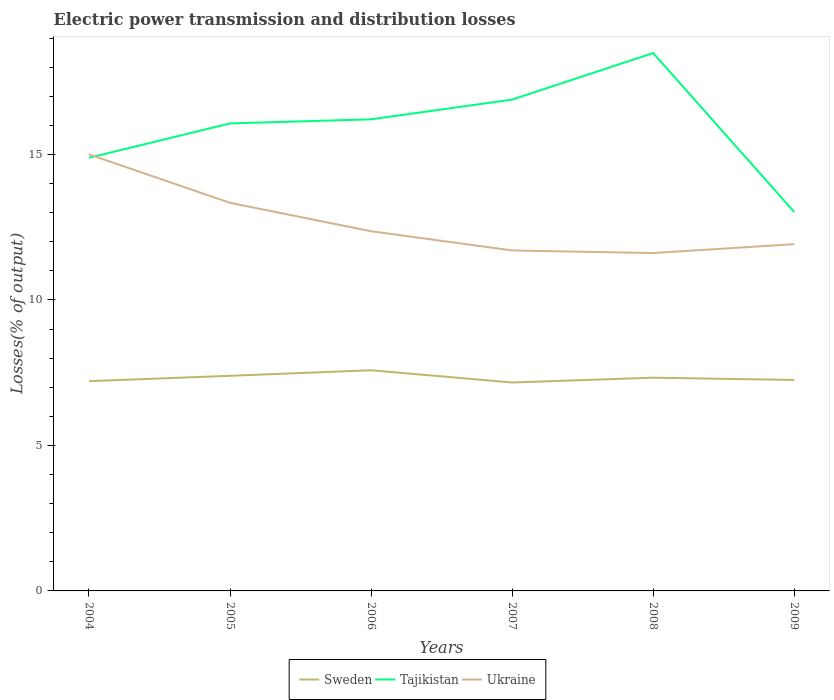Does the line corresponding to Ukraine intersect with the line corresponding to Tajikistan?
Give a very brief answer. Yes. Across all years, what is the maximum electric power transmission and distribution losses in Ukraine?
Your answer should be compact. 11.61. What is the total electric power transmission and distribution losses in Sweden in the graph?
Your response must be concise. -0.18. What is the difference between the highest and the second highest electric power transmission and distribution losses in Ukraine?
Keep it short and to the point. 3.39. What is the difference between the highest and the lowest electric power transmission and distribution losses in Sweden?
Provide a short and direct response. 3. Is the electric power transmission and distribution losses in Sweden strictly greater than the electric power transmission and distribution losses in Ukraine over the years?
Provide a short and direct response. Yes. How many years are there in the graph?
Your answer should be very brief. 6. What is the difference between two consecutive major ticks on the Y-axis?
Provide a succinct answer. 5. Where does the legend appear in the graph?
Ensure brevity in your answer.  Bottom center. How are the legend labels stacked?
Make the answer very short. Horizontal. What is the title of the graph?
Make the answer very short. Electric power transmission and distribution losses. What is the label or title of the Y-axis?
Offer a very short reply. Losses(% of output). What is the Losses(% of output) of Sweden in 2004?
Your response must be concise. 7.21. What is the Losses(% of output) in Tajikistan in 2004?
Keep it short and to the point. 14.89. What is the Losses(% of output) in Ukraine in 2004?
Your answer should be very brief. 15. What is the Losses(% of output) of Sweden in 2005?
Provide a succinct answer. 7.39. What is the Losses(% of output) of Tajikistan in 2005?
Your answer should be compact. 16.07. What is the Losses(% of output) in Ukraine in 2005?
Your answer should be very brief. 13.34. What is the Losses(% of output) in Sweden in 2006?
Provide a short and direct response. 7.58. What is the Losses(% of output) in Tajikistan in 2006?
Provide a succinct answer. 16.21. What is the Losses(% of output) in Ukraine in 2006?
Provide a succinct answer. 12.36. What is the Losses(% of output) in Sweden in 2007?
Offer a terse response. 7.16. What is the Losses(% of output) in Tajikistan in 2007?
Your answer should be very brief. 16.89. What is the Losses(% of output) in Ukraine in 2007?
Keep it short and to the point. 11.7. What is the Losses(% of output) in Sweden in 2008?
Give a very brief answer. 7.33. What is the Losses(% of output) of Tajikistan in 2008?
Make the answer very short. 18.49. What is the Losses(% of output) of Ukraine in 2008?
Keep it short and to the point. 11.61. What is the Losses(% of output) of Sweden in 2009?
Your answer should be very brief. 7.25. What is the Losses(% of output) in Tajikistan in 2009?
Make the answer very short. 13.02. What is the Losses(% of output) in Ukraine in 2009?
Give a very brief answer. 11.92. Across all years, what is the maximum Losses(% of output) in Sweden?
Keep it short and to the point. 7.58. Across all years, what is the maximum Losses(% of output) of Tajikistan?
Your answer should be compact. 18.49. Across all years, what is the maximum Losses(% of output) in Ukraine?
Make the answer very short. 15. Across all years, what is the minimum Losses(% of output) of Sweden?
Provide a short and direct response. 7.16. Across all years, what is the minimum Losses(% of output) of Tajikistan?
Offer a terse response. 13.02. Across all years, what is the minimum Losses(% of output) in Ukraine?
Your answer should be very brief. 11.61. What is the total Losses(% of output) in Sweden in the graph?
Provide a succinct answer. 43.93. What is the total Losses(% of output) of Tajikistan in the graph?
Give a very brief answer. 95.56. What is the total Losses(% of output) in Ukraine in the graph?
Offer a terse response. 75.94. What is the difference between the Losses(% of output) of Sweden in 2004 and that in 2005?
Make the answer very short. -0.18. What is the difference between the Losses(% of output) of Tajikistan in 2004 and that in 2005?
Make the answer very short. -1.18. What is the difference between the Losses(% of output) in Ukraine in 2004 and that in 2005?
Your answer should be very brief. 1.67. What is the difference between the Losses(% of output) in Sweden in 2004 and that in 2006?
Offer a very short reply. -0.37. What is the difference between the Losses(% of output) of Tajikistan in 2004 and that in 2006?
Your answer should be very brief. -1.32. What is the difference between the Losses(% of output) of Ukraine in 2004 and that in 2006?
Make the answer very short. 2.64. What is the difference between the Losses(% of output) of Sweden in 2004 and that in 2007?
Make the answer very short. 0.05. What is the difference between the Losses(% of output) of Tajikistan in 2004 and that in 2007?
Your response must be concise. -2. What is the difference between the Losses(% of output) in Ukraine in 2004 and that in 2007?
Offer a very short reply. 3.3. What is the difference between the Losses(% of output) of Sweden in 2004 and that in 2008?
Your answer should be very brief. -0.12. What is the difference between the Losses(% of output) of Tajikistan in 2004 and that in 2008?
Your answer should be compact. -3.6. What is the difference between the Losses(% of output) in Ukraine in 2004 and that in 2008?
Offer a terse response. 3.39. What is the difference between the Losses(% of output) in Sweden in 2004 and that in 2009?
Give a very brief answer. -0.04. What is the difference between the Losses(% of output) of Tajikistan in 2004 and that in 2009?
Your answer should be compact. 1.86. What is the difference between the Losses(% of output) in Ukraine in 2004 and that in 2009?
Offer a very short reply. 3.09. What is the difference between the Losses(% of output) in Sweden in 2005 and that in 2006?
Provide a succinct answer. -0.19. What is the difference between the Losses(% of output) of Tajikistan in 2005 and that in 2006?
Offer a very short reply. -0.14. What is the difference between the Losses(% of output) of Ukraine in 2005 and that in 2006?
Keep it short and to the point. 0.98. What is the difference between the Losses(% of output) in Sweden in 2005 and that in 2007?
Your response must be concise. 0.23. What is the difference between the Losses(% of output) in Tajikistan in 2005 and that in 2007?
Give a very brief answer. -0.82. What is the difference between the Losses(% of output) of Ukraine in 2005 and that in 2007?
Make the answer very short. 1.64. What is the difference between the Losses(% of output) of Sweden in 2005 and that in 2008?
Give a very brief answer. 0.07. What is the difference between the Losses(% of output) of Tajikistan in 2005 and that in 2008?
Your response must be concise. -2.42. What is the difference between the Losses(% of output) of Ukraine in 2005 and that in 2008?
Ensure brevity in your answer.  1.73. What is the difference between the Losses(% of output) of Sweden in 2005 and that in 2009?
Offer a terse response. 0.14. What is the difference between the Losses(% of output) of Tajikistan in 2005 and that in 2009?
Your response must be concise. 3.04. What is the difference between the Losses(% of output) in Ukraine in 2005 and that in 2009?
Provide a succinct answer. 1.42. What is the difference between the Losses(% of output) of Sweden in 2006 and that in 2007?
Offer a terse response. 0.42. What is the difference between the Losses(% of output) in Tajikistan in 2006 and that in 2007?
Provide a succinct answer. -0.68. What is the difference between the Losses(% of output) in Ukraine in 2006 and that in 2007?
Give a very brief answer. 0.66. What is the difference between the Losses(% of output) of Sweden in 2006 and that in 2008?
Your response must be concise. 0.26. What is the difference between the Losses(% of output) of Tajikistan in 2006 and that in 2008?
Make the answer very short. -2.28. What is the difference between the Losses(% of output) of Ukraine in 2006 and that in 2008?
Keep it short and to the point. 0.75. What is the difference between the Losses(% of output) of Sweden in 2006 and that in 2009?
Your response must be concise. 0.33. What is the difference between the Losses(% of output) in Tajikistan in 2006 and that in 2009?
Ensure brevity in your answer.  3.19. What is the difference between the Losses(% of output) of Ukraine in 2006 and that in 2009?
Your answer should be very brief. 0.44. What is the difference between the Losses(% of output) in Sweden in 2007 and that in 2008?
Make the answer very short. -0.17. What is the difference between the Losses(% of output) of Tajikistan in 2007 and that in 2008?
Make the answer very short. -1.6. What is the difference between the Losses(% of output) in Ukraine in 2007 and that in 2008?
Provide a succinct answer. 0.09. What is the difference between the Losses(% of output) in Sweden in 2007 and that in 2009?
Keep it short and to the point. -0.09. What is the difference between the Losses(% of output) in Tajikistan in 2007 and that in 2009?
Your response must be concise. 3.86. What is the difference between the Losses(% of output) of Ukraine in 2007 and that in 2009?
Provide a short and direct response. -0.22. What is the difference between the Losses(% of output) in Sweden in 2008 and that in 2009?
Provide a short and direct response. 0.08. What is the difference between the Losses(% of output) in Tajikistan in 2008 and that in 2009?
Provide a succinct answer. 5.46. What is the difference between the Losses(% of output) of Ukraine in 2008 and that in 2009?
Ensure brevity in your answer.  -0.31. What is the difference between the Losses(% of output) of Sweden in 2004 and the Losses(% of output) of Tajikistan in 2005?
Provide a short and direct response. -8.86. What is the difference between the Losses(% of output) of Sweden in 2004 and the Losses(% of output) of Ukraine in 2005?
Your answer should be compact. -6.13. What is the difference between the Losses(% of output) of Tajikistan in 2004 and the Losses(% of output) of Ukraine in 2005?
Offer a very short reply. 1.55. What is the difference between the Losses(% of output) in Sweden in 2004 and the Losses(% of output) in Tajikistan in 2006?
Your answer should be compact. -9. What is the difference between the Losses(% of output) in Sweden in 2004 and the Losses(% of output) in Ukraine in 2006?
Your response must be concise. -5.15. What is the difference between the Losses(% of output) of Tajikistan in 2004 and the Losses(% of output) of Ukraine in 2006?
Provide a succinct answer. 2.52. What is the difference between the Losses(% of output) in Sweden in 2004 and the Losses(% of output) in Tajikistan in 2007?
Keep it short and to the point. -9.68. What is the difference between the Losses(% of output) in Sweden in 2004 and the Losses(% of output) in Ukraine in 2007?
Offer a terse response. -4.49. What is the difference between the Losses(% of output) in Tajikistan in 2004 and the Losses(% of output) in Ukraine in 2007?
Your answer should be very brief. 3.18. What is the difference between the Losses(% of output) of Sweden in 2004 and the Losses(% of output) of Tajikistan in 2008?
Your answer should be very brief. -11.28. What is the difference between the Losses(% of output) of Sweden in 2004 and the Losses(% of output) of Ukraine in 2008?
Your response must be concise. -4.4. What is the difference between the Losses(% of output) in Tajikistan in 2004 and the Losses(% of output) in Ukraine in 2008?
Make the answer very short. 3.27. What is the difference between the Losses(% of output) of Sweden in 2004 and the Losses(% of output) of Tajikistan in 2009?
Your response must be concise. -5.81. What is the difference between the Losses(% of output) of Sweden in 2004 and the Losses(% of output) of Ukraine in 2009?
Your answer should be very brief. -4.71. What is the difference between the Losses(% of output) of Tajikistan in 2004 and the Losses(% of output) of Ukraine in 2009?
Make the answer very short. 2.97. What is the difference between the Losses(% of output) of Sweden in 2005 and the Losses(% of output) of Tajikistan in 2006?
Ensure brevity in your answer.  -8.82. What is the difference between the Losses(% of output) of Sweden in 2005 and the Losses(% of output) of Ukraine in 2006?
Provide a succinct answer. -4.97. What is the difference between the Losses(% of output) of Tajikistan in 2005 and the Losses(% of output) of Ukraine in 2006?
Give a very brief answer. 3.71. What is the difference between the Losses(% of output) in Sweden in 2005 and the Losses(% of output) in Tajikistan in 2007?
Make the answer very short. -9.49. What is the difference between the Losses(% of output) in Sweden in 2005 and the Losses(% of output) in Ukraine in 2007?
Your response must be concise. -4.31. What is the difference between the Losses(% of output) in Tajikistan in 2005 and the Losses(% of output) in Ukraine in 2007?
Give a very brief answer. 4.37. What is the difference between the Losses(% of output) of Sweden in 2005 and the Losses(% of output) of Tajikistan in 2008?
Offer a terse response. -11.09. What is the difference between the Losses(% of output) of Sweden in 2005 and the Losses(% of output) of Ukraine in 2008?
Offer a terse response. -4.22. What is the difference between the Losses(% of output) of Tajikistan in 2005 and the Losses(% of output) of Ukraine in 2008?
Ensure brevity in your answer.  4.46. What is the difference between the Losses(% of output) in Sweden in 2005 and the Losses(% of output) in Tajikistan in 2009?
Provide a short and direct response. -5.63. What is the difference between the Losses(% of output) of Sweden in 2005 and the Losses(% of output) of Ukraine in 2009?
Your response must be concise. -4.52. What is the difference between the Losses(% of output) of Tajikistan in 2005 and the Losses(% of output) of Ukraine in 2009?
Your response must be concise. 4.15. What is the difference between the Losses(% of output) of Sweden in 2006 and the Losses(% of output) of Tajikistan in 2007?
Keep it short and to the point. -9.3. What is the difference between the Losses(% of output) of Sweden in 2006 and the Losses(% of output) of Ukraine in 2007?
Ensure brevity in your answer.  -4.12. What is the difference between the Losses(% of output) of Tajikistan in 2006 and the Losses(% of output) of Ukraine in 2007?
Ensure brevity in your answer.  4.51. What is the difference between the Losses(% of output) in Sweden in 2006 and the Losses(% of output) in Tajikistan in 2008?
Your answer should be very brief. -10.9. What is the difference between the Losses(% of output) in Sweden in 2006 and the Losses(% of output) in Ukraine in 2008?
Offer a very short reply. -4.03. What is the difference between the Losses(% of output) of Tajikistan in 2006 and the Losses(% of output) of Ukraine in 2008?
Your response must be concise. 4.6. What is the difference between the Losses(% of output) in Sweden in 2006 and the Losses(% of output) in Tajikistan in 2009?
Give a very brief answer. -5.44. What is the difference between the Losses(% of output) in Sweden in 2006 and the Losses(% of output) in Ukraine in 2009?
Your response must be concise. -4.33. What is the difference between the Losses(% of output) of Tajikistan in 2006 and the Losses(% of output) of Ukraine in 2009?
Provide a short and direct response. 4.29. What is the difference between the Losses(% of output) in Sweden in 2007 and the Losses(% of output) in Tajikistan in 2008?
Give a very brief answer. -11.32. What is the difference between the Losses(% of output) in Sweden in 2007 and the Losses(% of output) in Ukraine in 2008?
Your response must be concise. -4.45. What is the difference between the Losses(% of output) in Tajikistan in 2007 and the Losses(% of output) in Ukraine in 2008?
Ensure brevity in your answer.  5.27. What is the difference between the Losses(% of output) in Sweden in 2007 and the Losses(% of output) in Tajikistan in 2009?
Your response must be concise. -5.86. What is the difference between the Losses(% of output) of Sweden in 2007 and the Losses(% of output) of Ukraine in 2009?
Ensure brevity in your answer.  -4.75. What is the difference between the Losses(% of output) of Tajikistan in 2007 and the Losses(% of output) of Ukraine in 2009?
Your response must be concise. 4.97. What is the difference between the Losses(% of output) of Sweden in 2008 and the Losses(% of output) of Tajikistan in 2009?
Make the answer very short. -5.7. What is the difference between the Losses(% of output) in Sweden in 2008 and the Losses(% of output) in Ukraine in 2009?
Provide a succinct answer. -4.59. What is the difference between the Losses(% of output) in Tajikistan in 2008 and the Losses(% of output) in Ukraine in 2009?
Provide a short and direct response. 6.57. What is the average Losses(% of output) of Sweden per year?
Offer a very short reply. 7.32. What is the average Losses(% of output) in Tajikistan per year?
Offer a terse response. 15.93. What is the average Losses(% of output) in Ukraine per year?
Give a very brief answer. 12.66. In the year 2004, what is the difference between the Losses(% of output) in Sweden and Losses(% of output) in Tajikistan?
Keep it short and to the point. -7.68. In the year 2004, what is the difference between the Losses(% of output) of Sweden and Losses(% of output) of Ukraine?
Your answer should be compact. -7.79. In the year 2004, what is the difference between the Losses(% of output) in Tajikistan and Losses(% of output) in Ukraine?
Offer a terse response. -0.12. In the year 2005, what is the difference between the Losses(% of output) in Sweden and Losses(% of output) in Tajikistan?
Provide a short and direct response. -8.67. In the year 2005, what is the difference between the Losses(% of output) of Sweden and Losses(% of output) of Ukraine?
Your answer should be compact. -5.94. In the year 2005, what is the difference between the Losses(% of output) in Tajikistan and Losses(% of output) in Ukraine?
Provide a short and direct response. 2.73. In the year 2006, what is the difference between the Losses(% of output) of Sweden and Losses(% of output) of Tajikistan?
Give a very brief answer. -8.62. In the year 2006, what is the difference between the Losses(% of output) of Sweden and Losses(% of output) of Ukraine?
Your response must be concise. -4.78. In the year 2006, what is the difference between the Losses(% of output) in Tajikistan and Losses(% of output) in Ukraine?
Make the answer very short. 3.85. In the year 2007, what is the difference between the Losses(% of output) of Sweden and Losses(% of output) of Tajikistan?
Ensure brevity in your answer.  -9.72. In the year 2007, what is the difference between the Losses(% of output) in Sweden and Losses(% of output) in Ukraine?
Ensure brevity in your answer.  -4.54. In the year 2007, what is the difference between the Losses(% of output) of Tajikistan and Losses(% of output) of Ukraine?
Your response must be concise. 5.18. In the year 2008, what is the difference between the Losses(% of output) in Sweden and Losses(% of output) in Tajikistan?
Make the answer very short. -11.16. In the year 2008, what is the difference between the Losses(% of output) in Sweden and Losses(% of output) in Ukraine?
Offer a very short reply. -4.28. In the year 2008, what is the difference between the Losses(% of output) in Tajikistan and Losses(% of output) in Ukraine?
Give a very brief answer. 6.87. In the year 2009, what is the difference between the Losses(% of output) of Sweden and Losses(% of output) of Tajikistan?
Give a very brief answer. -5.77. In the year 2009, what is the difference between the Losses(% of output) in Sweden and Losses(% of output) in Ukraine?
Your answer should be very brief. -4.67. In the year 2009, what is the difference between the Losses(% of output) in Tajikistan and Losses(% of output) in Ukraine?
Make the answer very short. 1.11. What is the ratio of the Losses(% of output) of Sweden in 2004 to that in 2005?
Offer a terse response. 0.98. What is the ratio of the Losses(% of output) of Tajikistan in 2004 to that in 2005?
Provide a short and direct response. 0.93. What is the ratio of the Losses(% of output) of Ukraine in 2004 to that in 2005?
Your response must be concise. 1.12. What is the ratio of the Losses(% of output) of Sweden in 2004 to that in 2006?
Offer a terse response. 0.95. What is the ratio of the Losses(% of output) in Tajikistan in 2004 to that in 2006?
Your response must be concise. 0.92. What is the ratio of the Losses(% of output) in Ukraine in 2004 to that in 2006?
Ensure brevity in your answer.  1.21. What is the ratio of the Losses(% of output) of Sweden in 2004 to that in 2007?
Make the answer very short. 1.01. What is the ratio of the Losses(% of output) in Tajikistan in 2004 to that in 2007?
Ensure brevity in your answer.  0.88. What is the ratio of the Losses(% of output) in Ukraine in 2004 to that in 2007?
Give a very brief answer. 1.28. What is the ratio of the Losses(% of output) in Sweden in 2004 to that in 2008?
Offer a very short reply. 0.98. What is the ratio of the Losses(% of output) in Tajikistan in 2004 to that in 2008?
Give a very brief answer. 0.81. What is the ratio of the Losses(% of output) in Ukraine in 2004 to that in 2008?
Your response must be concise. 1.29. What is the ratio of the Losses(% of output) in Tajikistan in 2004 to that in 2009?
Offer a very short reply. 1.14. What is the ratio of the Losses(% of output) of Ukraine in 2004 to that in 2009?
Make the answer very short. 1.26. What is the ratio of the Losses(% of output) of Sweden in 2005 to that in 2006?
Provide a short and direct response. 0.97. What is the ratio of the Losses(% of output) in Tajikistan in 2005 to that in 2006?
Provide a succinct answer. 0.99. What is the ratio of the Losses(% of output) of Ukraine in 2005 to that in 2006?
Give a very brief answer. 1.08. What is the ratio of the Losses(% of output) of Sweden in 2005 to that in 2007?
Provide a short and direct response. 1.03. What is the ratio of the Losses(% of output) in Tajikistan in 2005 to that in 2007?
Make the answer very short. 0.95. What is the ratio of the Losses(% of output) in Ukraine in 2005 to that in 2007?
Your answer should be very brief. 1.14. What is the ratio of the Losses(% of output) of Sweden in 2005 to that in 2008?
Ensure brevity in your answer.  1.01. What is the ratio of the Losses(% of output) in Tajikistan in 2005 to that in 2008?
Ensure brevity in your answer.  0.87. What is the ratio of the Losses(% of output) in Ukraine in 2005 to that in 2008?
Give a very brief answer. 1.15. What is the ratio of the Losses(% of output) of Sweden in 2005 to that in 2009?
Your answer should be very brief. 1.02. What is the ratio of the Losses(% of output) in Tajikistan in 2005 to that in 2009?
Make the answer very short. 1.23. What is the ratio of the Losses(% of output) of Ukraine in 2005 to that in 2009?
Provide a short and direct response. 1.12. What is the ratio of the Losses(% of output) in Sweden in 2006 to that in 2007?
Your response must be concise. 1.06. What is the ratio of the Losses(% of output) of Tajikistan in 2006 to that in 2007?
Keep it short and to the point. 0.96. What is the ratio of the Losses(% of output) in Ukraine in 2006 to that in 2007?
Keep it short and to the point. 1.06. What is the ratio of the Losses(% of output) in Sweden in 2006 to that in 2008?
Your response must be concise. 1.03. What is the ratio of the Losses(% of output) of Tajikistan in 2006 to that in 2008?
Make the answer very short. 0.88. What is the ratio of the Losses(% of output) of Ukraine in 2006 to that in 2008?
Your answer should be very brief. 1.06. What is the ratio of the Losses(% of output) in Sweden in 2006 to that in 2009?
Give a very brief answer. 1.05. What is the ratio of the Losses(% of output) of Tajikistan in 2006 to that in 2009?
Make the answer very short. 1.24. What is the ratio of the Losses(% of output) in Ukraine in 2006 to that in 2009?
Give a very brief answer. 1.04. What is the ratio of the Losses(% of output) of Sweden in 2007 to that in 2008?
Keep it short and to the point. 0.98. What is the ratio of the Losses(% of output) of Tajikistan in 2007 to that in 2008?
Your response must be concise. 0.91. What is the ratio of the Losses(% of output) of Tajikistan in 2007 to that in 2009?
Provide a short and direct response. 1.3. What is the ratio of the Losses(% of output) of Ukraine in 2007 to that in 2009?
Make the answer very short. 0.98. What is the ratio of the Losses(% of output) of Sweden in 2008 to that in 2009?
Offer a terse response. 1.01. What is the ratio of the Losses(% of output) of Tajikistan in 2008 to that in 2009?
Provide a succinct answer. 1.42. What is the ratio of the Losses(% of output) of Ukraine in 2008 to that in 2009?
Offer a terse response. 0.97. What is the difference between the highest and the second highest Losses(% of output) in Sweden?
Offer a very short reply. 0.19. What is the difference between the highest and the second highest Losses(% of output) of Tajikistan?
Keep it short and to the point. 1.6. What is the difference between the highest and the second highest Losses(% of output) of Ukraine?
Offer a very short reply. 1.67. What is the difference between the highest and the lowest Losses(% of output) of Sweden?
Give a very brief answer. 0.42. What is the difference between the highest and the lowest Losses(% of output) of Tajikistan?
Offer a very short reply. 5.46. What is the difference between the highest and the lowest Losses(% of output) in Ukraine?
Give a very brief answer. 3.39. 